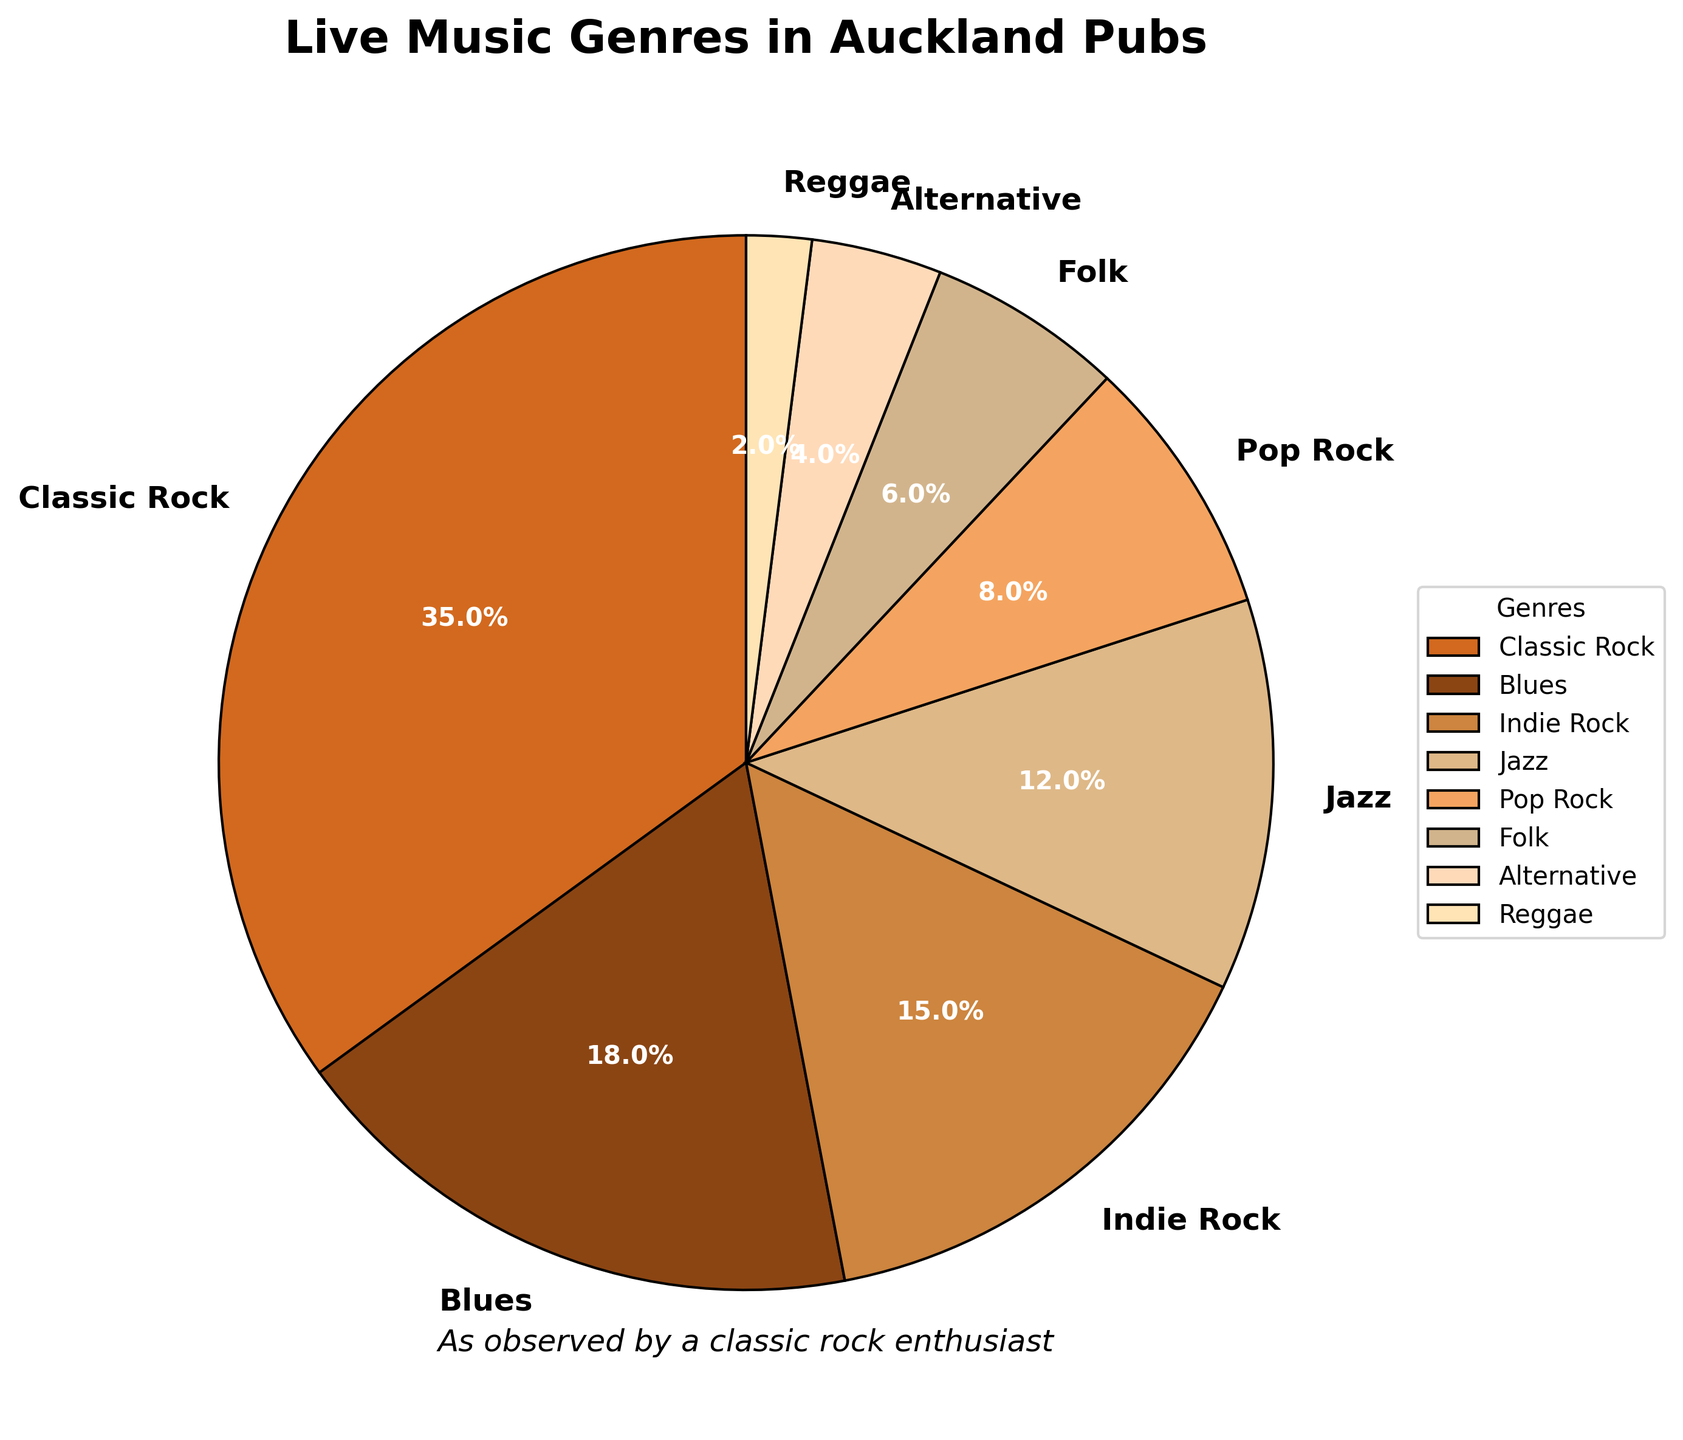which genre has the highest percentage representation? Classic Rock has the highest percentage representation which can be determined by looking at the segment size in the pie chart. The segment representing Classic Rock is the largest and labeled as 35%.
Answer: Classic Rock how many genres have a percentage of 10% or more? To determine the genres with a percentage of 10% or more, we look at the pie chart and count the segments labeled with percentages of at least 10%. Classic Rock, Blues, Indie Rock, and Jazz each have representations of 10% or more, totaling 4 genres.
Answer: 4 which genres combined make up less than 10% of the total together? To find the genres that make up less than 10% of the total together, we look for segments labeled with percentages that, when summed, are less than 10%. Reggae, with 2%, and Alternative, with 4%, add up to 6%, meeting this criteria. Together, they account for less than 10%.
Answer: Reggae, Alternative what is the difference in representation percentage between Classic Rock and Pop Rock? To determine the difference in representation percentage between Classic Rock and Pop Rock, subtract the percentage of Pop Rock (8%) from the percentage of Classic Rock (35%): 35% - 8% = 27%.
Answer: 27% which genre is represented by the lightest color in the chart? The lightest color in the pie chart typically represents the lowest percentage. The smallest segment is colored in the lightest shade and labeled as Reggae, with a percentage of 2%.
Answer: Reggae which two genres together make up the same percentage as Blues? Blues has a representation of 18%. By looking at the chart, we identify two genres whose combined percentages equal 18%. Pop Rock (8%) and Folk (6%) together add up to 14%, so we need to include another genre to make 18%. Therefore, Pop Rock (8%) and Jazz (12%) together make 20%, slightly exceeding 18%. The correct combination is Indie Rock (15%) and Reggae (2%) adding up to 17%, or Folk (6%) and Alternative (4%) adding up to 10%. So, Indie Rock (15%) and Alternative (4%) sum is 15+4=19%, closest to 18%.
Answer: Pop Rock and Jazz how many genres are shown in the pie chart? To determine the total number of genres shown in the pie chart, we count the number of labeled segments in the chart. There are 8 different genres represented.
Answer: 8 